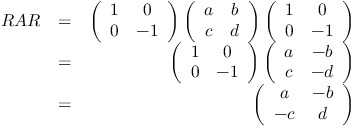<formula> <loc_0><loc_0><loc_500><loc_500>\begin{array} { r l r } { R A R } & { = } & { \left ( \begin{array} { c c } { 1 } & { 0 } \\ { 0 } & { - 1 } \end{array} \right ) \left ( \begin{array} { c c } { a } & { b } \\ { c } & { d } \end{array} \right ) \left ( \begin{array} { c c } { 1 } & { 0 } \\ { 0 } & { - 1 } \end{array} \right ) } \\ & { = } & { \left ( \begin{array} { c c } { 1 } & { 0 } \\ { 0 } & { - 1 } \end{array} \right ) \left ( \begin{array} { c c } { a } & { - b } \\ { c } & { - d } \end{array} \right ) } \\ & { = } & { \left ( \begin{array} { c c } { a } & { - b } \\ { - c } & { d } \end{array} \right ) } \end{array}</formula> 